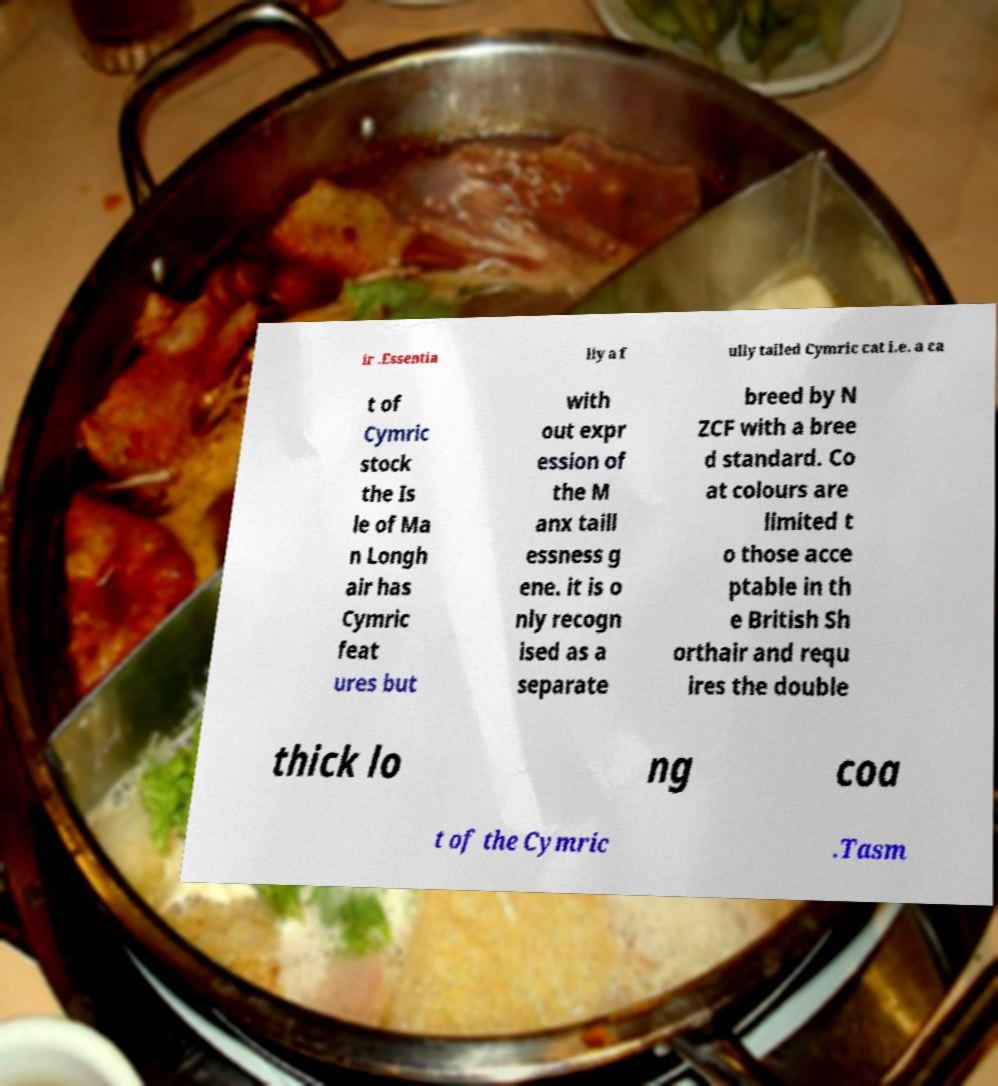Please read and relay the text visible in this image. What does it say? ir .Essentia lly a f ully tailed Cymric cat i.e. a ca t of Cymric stock the Is le of Ma n Longh air has Cymric feat ures but with out expr ession of the M anx taill essness g ene. it is o nly recogn ised as a separate breed by N ZCF with a bree d standard. Co at colours are limited t o those acce ptable in th e British Sh orthair and requ ires the double thick lo ng coa t of the Cymric .Tasm 